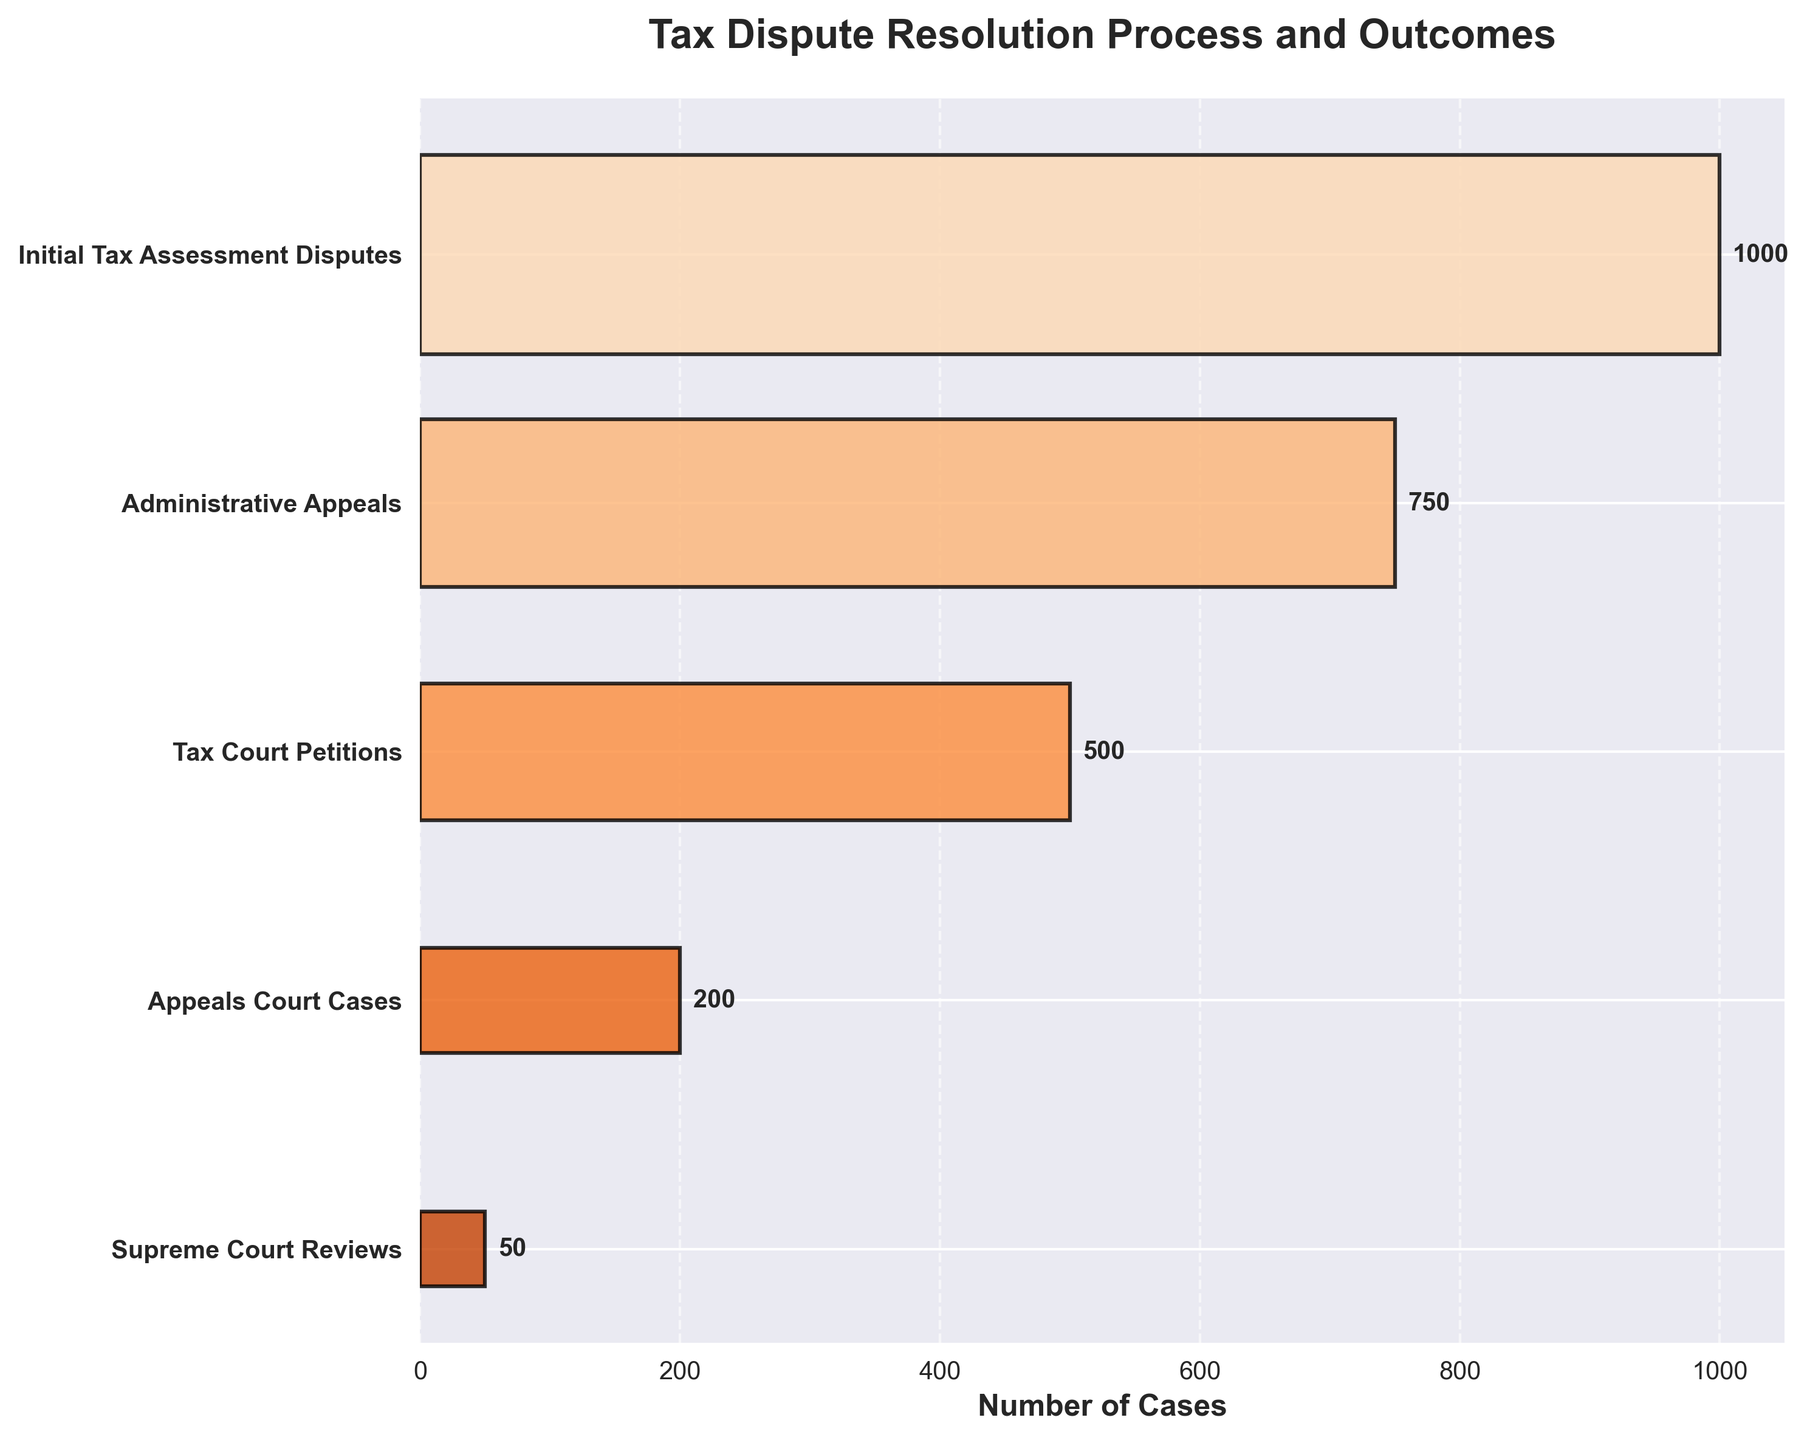What is the title of the figure? The title of the figure is located at the top and provides a summary of the chart's content. In this case, the title indicates it is about the Tax Dispute Resolution Process and Outcomes.
Answer: Tax Dispute Resolution Process and Outcomes How many stages are represented in the funnel chart? Count the number of y-tick labels on the vertical axis which represent each stage in the funnel chart.
Answer: 5 What is the number of cases at the Initial Tax Assessment Disputes stage? The number of cases at each stage is represented by a horizontal bar with a numerical label. Look at the label for the Initial Tax Assessment Disputes stage.
Answer: 1000 How many cases are there at the stage before the Supreme Court Reviews? Identify the stage directly above the Supreme Court Reviews on the vertical axis, which is the Appeals Court Cases. Then, look at its corresponding bar for the number of cases.
Answer: 200 Which stage has the least number of cases? Compare the length of the horizontal bars and their numerical labels. The shortest bar will have the least number of cases.
Answer: Supreme Court Reviews What is the total number of cases after the Initial Tax Assessment Disputes stage? Sum up the number of cases for the stages after Initial Tax Assessment Disputes: (750 + 500 + 200 + 50).
Answer: 1500 How many more cases are handled at the Administrative Appeals stage compared to the Appeals Court Cases stage? Subtract the number of cases at Appeals Court Cases (200) from the number of cases at Administrative Appeals (750).
Answer: 550 Which stage experiences the largest drop in the number of cases compared to the previous stage? Calculate the difference in cases between consecutive stages and find the largest drop: (1000 - 750, 750 - 500, 500 - 200, 200 - 50). The largest drop is between Administrative Appeals and Tax Court Petitions.
Answer: Administrative Appeals to Tax Court Petitions What proportion of the initial cases reach the Supreme Court Review stage? Divide the number of Supreme Court Review cases by the number of Initial Tax Assessment Disputes cases: 50/1000 = 0.05 or 5%.
Answer: 5% How is the width of the bars in the funnel chart affected from top to bottom? Observe the bars from top to bottom. Their width gradually decreases to represent the narrowing of cases through each stage.
Answer: Decreases 